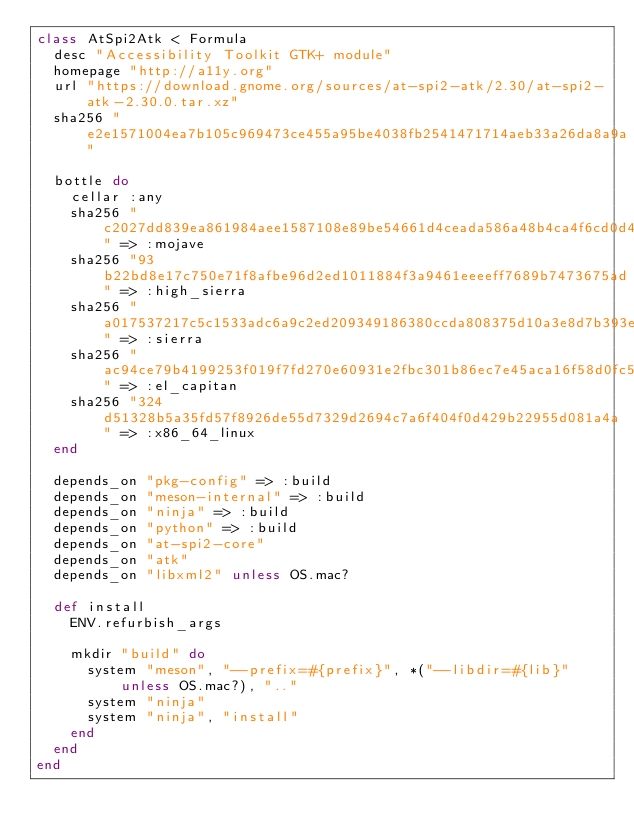<code> <loc_0><loc_0><loc_500><loc_500><_Ruby_>class AtSpi2Atk < Formula
  desc "Accessibility Toolkit GTK+ module"
  homepage "http://a11y.org"
  url "https://download.gnome.org/sources/at-spi2-atk/2.30/at-spi2-atk-2.30.0.tar.xz"
  sha256 "e2e1571004ea7b105c969473ce455a95be4038fb2541471714aeb33a26da8a9a"

  bottle do
    cellar :any
    sha256 "c2027dd839ea861984aee1587108e89be54661d4ceada586a48b4ca4f6cd0d41" => :mojave
    sha256 "93b22bd8e17c750e71f8afbe96d2ed1011884f3a9461eeeeff7689b7473675ad" => :high_sierra
    sha256 "a017537217c5c1533adc6a9c2ed209349186380ccda808375d10a3e8d7b393ed" => :sierra
    sha256 "ac94ce79b4199253f019f7fd270e60931e2fbc301b86ec7e45aca16f58d0fc58" => :el_capitan
    sha256 "324d51328b5a35fd57f8926de55d7329d2694c7a6f404f0d429b22955d081a4a" => :x86_64_linux
  end

  depends_on "pkg-config" => :build
  depends_on "meson-internal" => :build
  depends_on "ninja" => :build
  depends_on "python" => :build
  depends_on "at-spi2-core"
  depends_on "atk"
  depends_on "libxml2" unless OS.mac?

  def install
    ENV.refurbish_args

    mkdir "build" do
      system "meson", "--prefix=#{prefix}", *("--libdir=#{lib}" unless OS.mac?), ".."
      system "ninja"
      system "ninja", "install"
    end
  end
end
</code> 